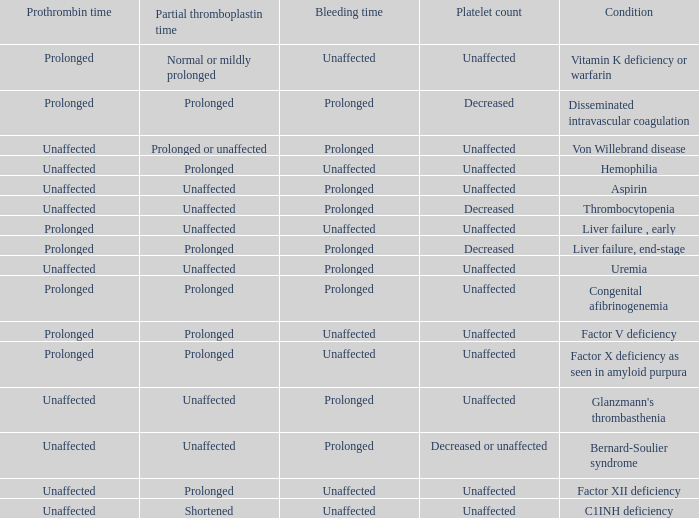Which Platelet count has a Condition of factor v deficiency? Unaffected. 